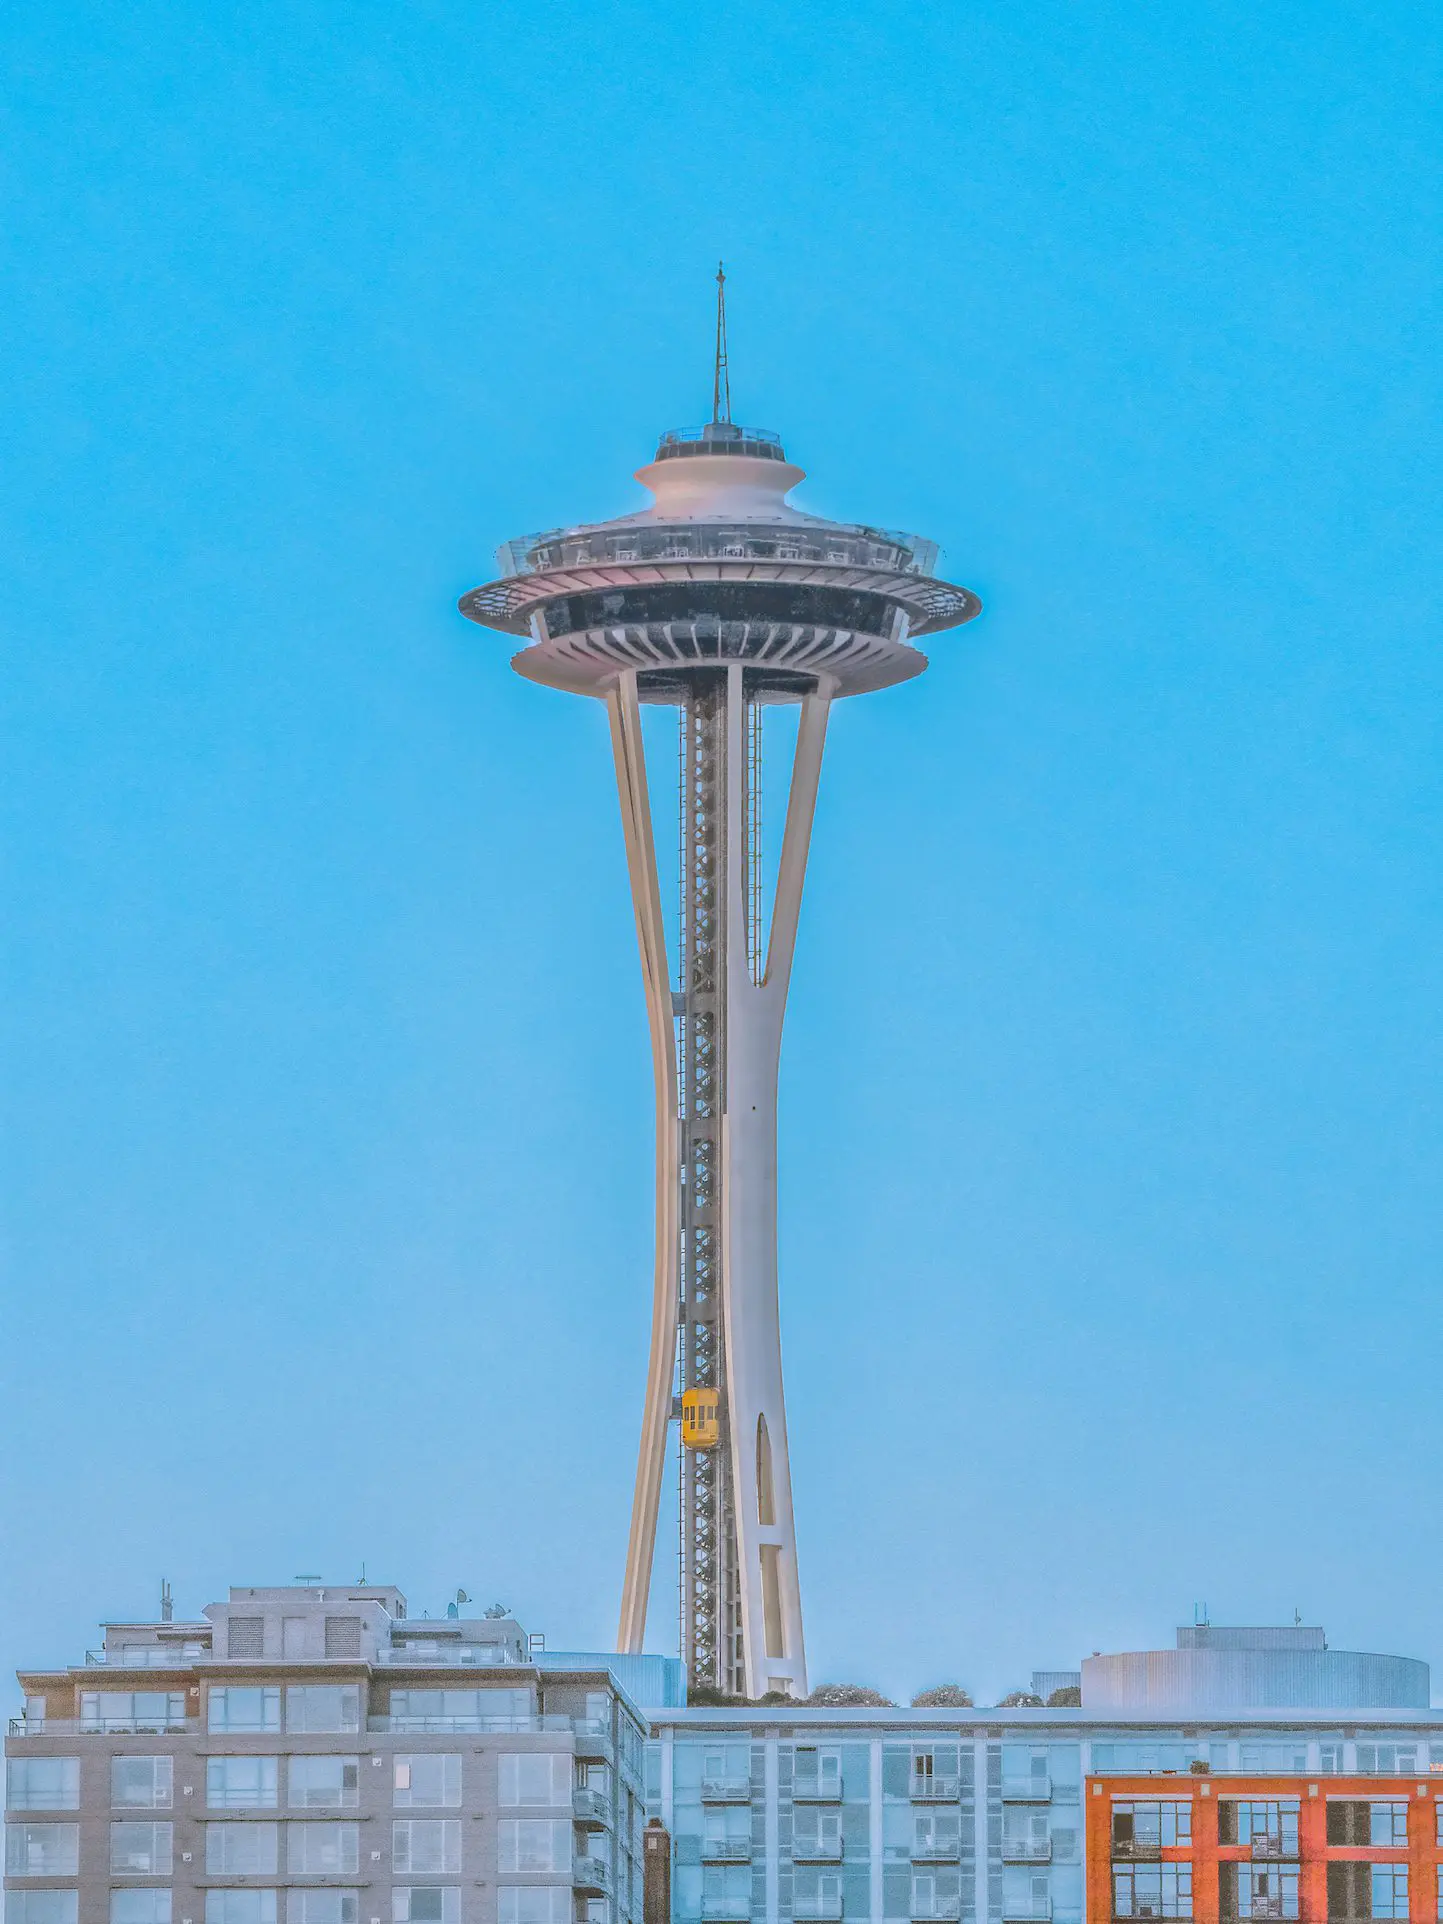Tell me more about the Space Needle. The Space Needle, an iconic structure of Seattle, was built for the 1962 World's Fair. It stands at 605 feet and was once the tallest structure west of the Mississippi River. The futuristic design was inspired by the Space Age and represented the optimism of the era. At its apex, it boasts an observation deck with 360-degree views, a rotating restaurant, and scenic vistas of the city and beyond, including the stunning Cascade and Olympic mountain ranges. Was the Space Needle always white and orange? The Space Needle's original colors were 'Galaxy Gold' for the top and 'Orbital Olive', 'Re-entry Red', and 'Astronaut White' for its other parts. It was repainted in these original colors for its 50th anniversary in 2012, but generally, maintains a white and sometimes more muted tones to align with its modern image and the Seattle skyline. Imagine a whimsical scenario involving the Space Needle. In a fantastical turn of events, imagine the Space Needle transformed into a colossal spaceship, lifting off gracefully from Seattle's grounds. Lights beam from its observation deck, and as it ascends, it trails cosmic dust glittering, creating a bridge of stars connecting Earth to distant galaxies. Residents of Seattle gaze in awe from below as the once stationary landmark now embarks on an intergalactic adventure, exploring unknown planets, encountering alien civilizations, and becoming a symbol of Earth’s quest for knowledge and discovery. 